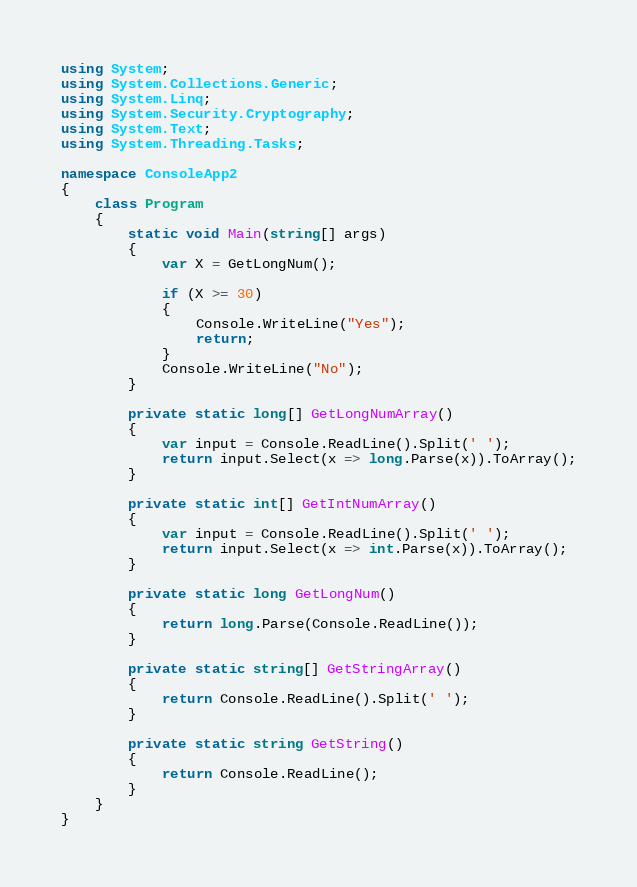Convert code to text. <code><loc_0><loc_0><loc_500><loc_500><_C#_>using System;
using System.Collections.Generic;
using System.Linq;
using System.Security.Cryptography;
using System.Text;
using System.Threading.Tasks;

namespace ConsoleApp2
{
    class Program
    {
        static void Main(string[] args)
        {
            var X = GetLongNum();

            if (X >= 30)
            {
                Console.WriteLine("Yes");
                return;
            }
            Console.WriteLine("No");
        }

        private static long[] GetLongNumArray()
        {
            var input = Console.ReadLine().Split(' ');
            return input.Select(x => long.Parse(x)).ToArray();
        }

        private static int[] GetIntNumArray()
        {
            var input = Console.ReadLine().Split(' ');
            return input.Select(x => int.Parse(x)).ToArray();
        }

        private static long GetLongNum()
        {
            return long.Parse(Console.ReadLine());
        }

        private static string[] GetStringArray()
        {
            return Console.ReadLine().Split(' ');
        }

        private static string GetString()
        {
            return Console.ReadLine();
        }
    }
}
</code> 